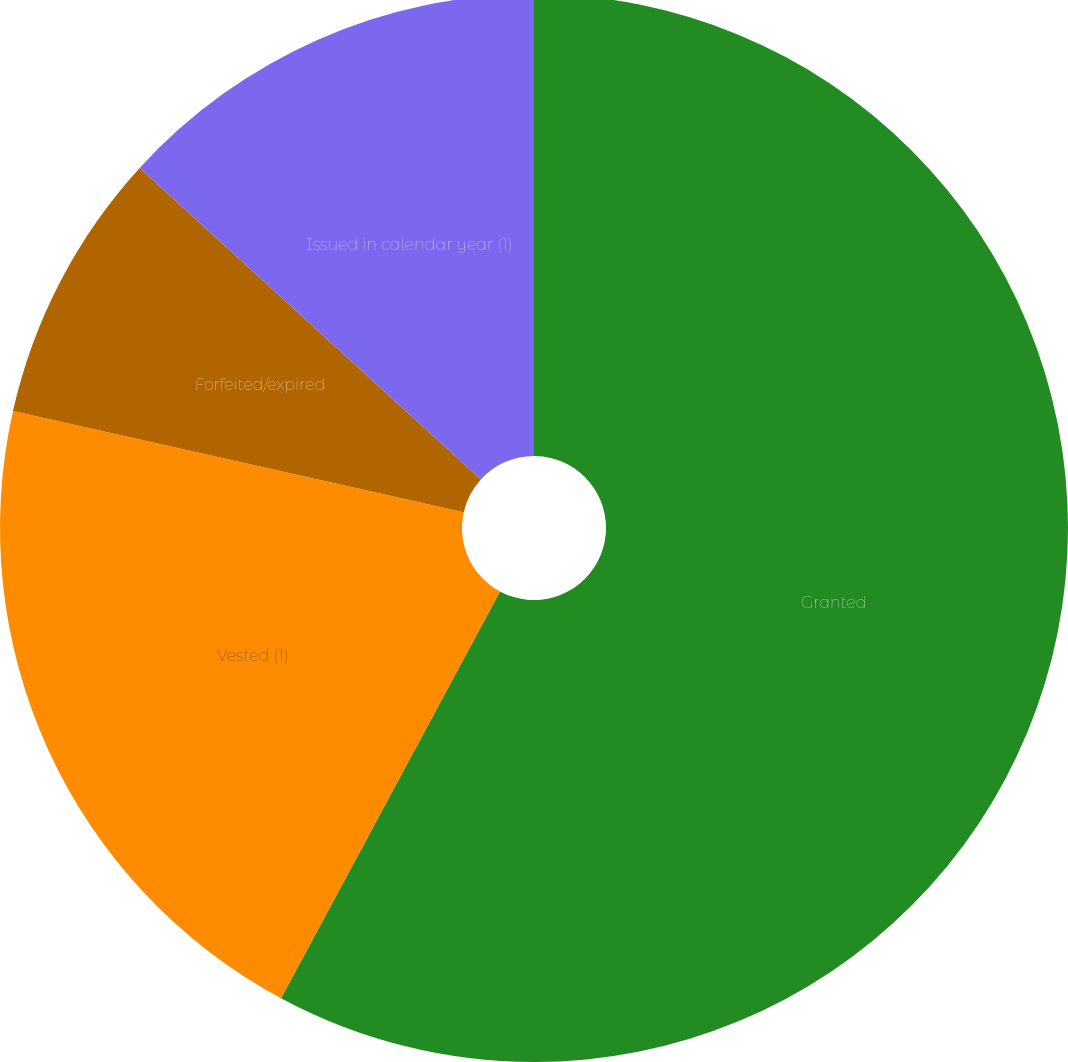Convert chart. <chart><loc_0><loc_0><loc_500><loc_500><pie_chart><fcel>Granted<fcel>Vested (1)<fcel>Forfeited/expired<fcel>Issued in calendar year (1)<nl><fcel>57.85%<fcel>20.66%<fcel>8.26%<fcel>13.22%<nl></chart> 